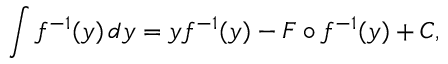Convert formula to latex. <formula><loc_0><loc_0><loc_500><loc_500>\int f ^ { - 1 } ( y ) \, d y = y f ^ { - 1 } ( y ) - F \circ f ^ { - 1 } ( y ) + C ,</formula> 